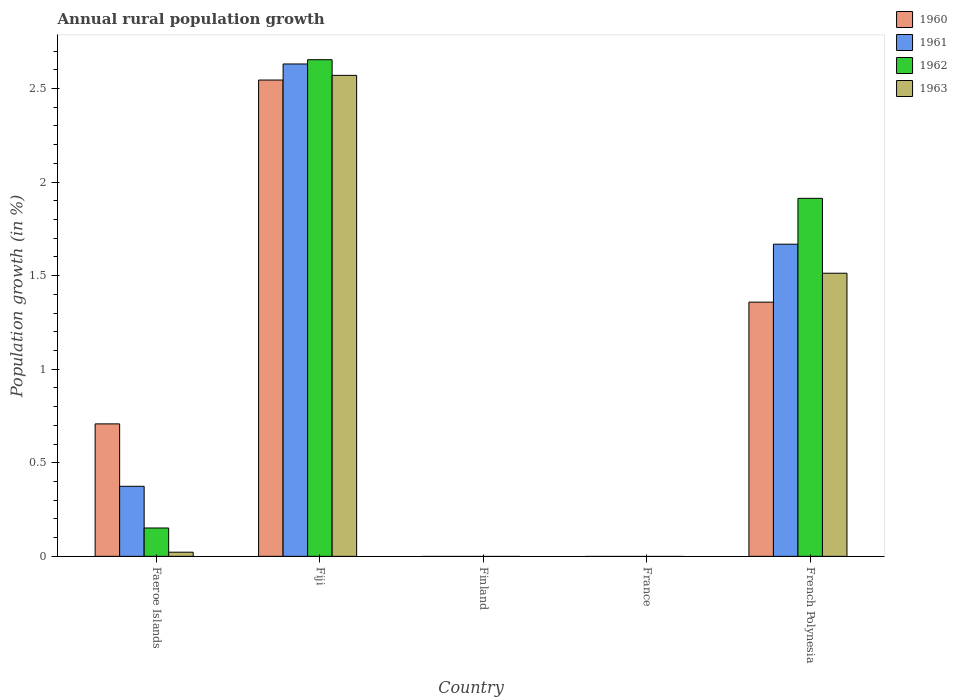Are the number of bars per tick equal to the number of legend labels?
Your response must be concise. No. How many bars are there on the 2nd tick from the left?
Offer a terse response. 4. What is the label of the 2nd group of bars from the left?
Provide a short and direct response. Fiji. In how many cases, is the number of bars for a given country not equal to the number of legend labels?
Offer a terse response. 2. Across all countries, what is the maximum percentage of rural population growth in 1963?
Offer a very short reply. 2.57. Across all countries, what is the minimum percentage of rural population growth in 1961?
Your answer should be very brief. 0. In which country was the percentage of rural population growth in 1962 maximum?
Your response must be concise. Fiji. What is the total percentage of rural population growth in 1961 in the graph?
Offer a very short reply. 4.67. What is the difference between the percentage of rural population growth in 1962 in Faeroe Islands and that in French Polynesia?
Your answer should be compact. -1.76. What is the difference between the percentage of rural population growth in 1963 in Fiji and the percentage of rural population growth in 1960 in France?
Your response must be concise. 2.57. What is the average percentage of rural population growth in 1962 per country?
Offer a very short reply. 0.94. What is the difference between the percentage of rural population growth of/in 1962 and percentage of rural population growth of/in 1961 in Fiji?
Provide a short and direct response. 0.02. In how many countries, is the percentage of rural population growth in 1963 greater than 2.4 %?
Offer a very short reply. 1. Is the difference between the percentage of rural population growth in 1962 in Fiji and French Polynesia greater than the difference between the percentage of rural population growth in 1961 in Fiji and French Polynesia?
Give a very brief answer. No. What is the difference between the highest and the second highest percentage of rural population growth in 1962?
Provide a succinct answer. -1.76. What is the difference between the highest and the lowest percentage of rural population growth in 1963?
Offer a terse response. 2.57. In how many countries, is the percentage of rural population growth in 1963 greater than the average percentage of rural population growth in 1963 taken over all countries?
Provide a short and direct response. 2. Is it the case that in every country, the sum of the percentage of rural population growth in 1963 and percentage of rural population growth in 1962 is greater than the percentage of rural population growth in 1960?
Offer a terse response. No. Are the values on the major ticks of Y-axis written in scientific E-notation?
Make the answer very short. No. Does the graph contain grids?
Your answer should be compact. No. Where does the legend appear in the graph?
Provide a short and direct response. Top right. How many legend labels are there?
Provide a succinct answer. 4. What is the title of the graph?
Offer a terse response. Annual rural population growth. Does "2000" appear as one of the legend labels in the graph?
Your answer should be very brief. No. What is the label or title of the X-axis?
Your answer should be very brief. Country. What is the label or title of the Y-axis?
Your answer should be very brief. Population growth (in %). What is the Population growth (in %) in 1960 in Faeroe Islands?
Ensure brevity in your answer.  0.71. What is the Population growth (in %) of 1961 in Faeroe Islands?
Offer a very short reply. 0.37. What is the Population growth (in %) in 1962 in Faeroe Islands?
Keep it short and to the point. 0.15. What is the Population growth (in %) in 1963 in Faeroe Islands?
Make the answer very short. 0.02. What is the Population growth (in %) in 1960 in Fiji?
Offer a very short reply. 2.54. What is the Population growth (in %) of 1961 in Fiji?
Offer a very short reply. 2.63. What is the Population growth (in %) of 1962 in Fiji?
Your response must be concise. 2.65. What is the Population growth (in %) of 1963 in Fiji?
Ensure brevity in your answer.  2.57. What is the Population growth (in %) of 1963 in Finland?
Give a very brief answer. 0. What is the Population growth (in %) of 1960 in France?
Provide a succinct answer. 0. What is the Population growth (in %) of 1960 in French Polynesia?
Provide a succinct answer. 1.36. What is the Population growth (in %) of 1961 in French Polynesia?
Provide a succinct answer. 1.67. What is the Population growth (in %) of 1962 in French Polynesia?
Offer a very short reply. 1.91. What is the Population growth (in %) of 1963 in French Polynesia?
Make the answer very short. 1.51. Across all countries, what is the maximum Population growth (in %) of 1960?
Offer a terse response. 2.54. Across all countries, what is the maximum Population growth (in %) of 1961?
Offer a terse response. 2.63. Across all countries, what is the maximum Population growth (in %) of 1962?
Your answer should be very brief. 2.65. Across all countries, what is the maximum Population growth (in %) of 1963?
Ensure brevity in your answer.  2.57. What is the total Population growth (in %) in 1960 in the graph?
Provide a succinct answer. 4.61. What is the total Population growth (in %) of 1961 in the graph?
Offer a terse response. 4.67. What is the total Population growth (in %) in 1962 in the graph?
Your response must be concise. 4.72. What is the total Population growth (in %) in 1963 in the graph?
Give a very brief answer. 4.1. What is the difference between the Population growth (in %) of 1960 in Faeroe Islands and that in Fiji?
Provide a short and direct response. -1.84. What is the difference between the Population growth (in %) in 1961 in Faeroe Islands and that in Fiji?
Provide a succinct answer. -2.26. What is the difference between the Population growth (in %) of 1962 in Faeroe Islands and that in Fiji?
Offer a very short reply. -2.5. What is the difference between the Population growth (in %) of 1963 in Faeroe Islands and that in Fiji?
Your answer should be compact. -2.55. What is the difference between the Population growth (in %) in 1960 in Faeroe Islands and that in French Polynesia?
Provide a succinct answer. -0.65. What is the difference between the Population growth (in %) of 1961 in Faeroe Islands and that in French Polynesia?
Give a very brief answer. -1.29. What is the difference between the Population growth (in %) in 1962 in Faeroe Islands and that in French Polynesia?
Provide a short and direct response. -1.76. What is the difference between the Population growth (in %) in 1963 in Faeroe Islands and that in French Polynesia?
Provide a short and direct response. -1.49. What is the difference between the Population growth (in %) of 1960 in Fiji and that in French Polynesia?
Your answer should be compact. 1.19. What is the difference between the Population growth (in %) in 1961 in Fiji and that in French Polynesia?
Your answer should be very brief. 0.96. What is the difference between the Population growth (in %) of 1962 in Fiji and that in French Polynesia?
Provide a short and direct response. 0.74. What is the difference between the Population growth (in %) of 1963 in Fiji and that in French Polynesia?
Make the answer very short. 1.06. What is the difference between the Population growth (in %) in 1960 in Faeroe Islands and the Population growth (in %) in 1961 in Fiji?
Give a very brief answer. -1.92. What is the difference between the Population growth (in %) in 1960 in Faeroe Islands and the Population growth (in %) in 1962 in Fiji?
Keep it short and to the point. -1.95. What is the difference between the Population growth (in %) in 1960 in Faeroe Islands and the Population growth (in %) in 1963 in Fiji?
Give a very brief answer. -1.86. What is the difference between the Population growth (in %) in 1961 in Faeroe Islands and the Population growth (in %) in 1962 in Fiji?
Give a very brief answer. -2.28. What is the difference between the Population growth (in %) of 1961 in Faeroe Islands and the Population growth (in %) of 1963 in Fiji?
Keep it short and to the point. -2.2. What is the difference between the Population growth (in %) of 1962 in Faeroe Islands and the Population growth (in %) of 1963 in Fiji?
Ensure brevity in your answer.  -2.42. What is the difference between the Population growth (in %) in 1960 in Faeroe Islands and the Population growth (in %) in 1961 in French Polynesia?
Make the answer very short. -0.96. What is the difference between the Population growth (in %) in 1960 in Faeroe Islands and the Population growth (in %) in 1962 in French Polynesia?
Ensure brevity in your answer.  -1.21. What is the difference between the Population growth (in %) in 1960 in Faeroe Islands and the Population growth (in %) in 1963 in French Polynesia?
Your response must be concise. -0.8. What is the difference between the Population growth (in %) of 1961 in Faeroe Islands and the Population growth (in %) of 1962 in French Polynesia?
Provide a short and direct response. -1.54. What is the difference between the Population growth (in %) in 1961 in Faeroe Islands and the Population growth (in %) in 1963 in French Polynesia?
Offer a terse response. -1.14. What is the difference between the Population growth (in %) in 1962 in Faeroe Islands and the Population growth (in %) in 1963 in French Polynesia?
Your answer should be compact. -1.36. What is the difference between the Population growth (in %) in 1960 in Fiji and the Population growth (in %) in 1961 in French Polynesia?
Offer a very short reply. 0.88. What is the difference between the Population growth (in %) of 1960 in Fiji and the Population growth (in %) of 1962 in French Polynesia?
Keep it short and to the point. 0.63. What is the difference between the Population growth (in %) in 1960 in Fiji and the Population growth (in %) in 1963 in French Polynesia?
Make the answer very short. 1.03. What is the difference between the Population growth (in %) in 1961 in Fiji and the Population growth (in %) in 1962 in French Polynesia?
Make the answer very short. 0.72. What is the difference between the Population growth (in %) of 1961 in Fiji and the Population growth (in %) of 1963 in French Polynesia?
Provide a succinct answer. 1.12. What is the difference between the Population growth (in %) of 1962 in Fiji and the Population growth (in %) of 1963 in French Polynesia?
Offer a terse response. 1.14. What is the average Population growth (in %) of 1960 per country?
Give a very brief answer. 0.92. What is the average Population growth (in %) in 1961 per country?
Keep it short and to the point. 0.93. What is the average Population growth (in %) in 1962 per country?
Give a very brief answer. 0.94. What is the average Population growth (in %) in 1963 per country?
Provide a succinct answer. 0.82. What is the difference between the Population growth (in %) of 1960 and Population growth (in %) of 1961 in Faeroe Islands?
Ensure brevity in your answer.  0.33. What is the difference between the Population growth (in %) in 1960 and Population growth (in %) in 1962 in Faeroe Islands?
Your answer should be very brief. 0.56. What is the difference between the Population growth (in %) of 1960 and Population growth (in %) of 1963 in Faeroe Islands?
Keep it short and to the point. 0.69. What is the difference between the Population growth (in %) in 1961 and Population growth (in %) in 1962 in Faeroe Islands?
Provide a short and direct response. 0.22. What is the difference between the Population growth (in %) in 1961 and Population growth (in %) in 1963 in Faeroe Islands?
Make the answer very short. 0.35. What is the difference between the Population growth (in %) in 1962 and Population growth (in %) in 1963 in Faeroe Islands?
Your answer should be very brief. 0.13. What is the difference between the Population growth (in %) of 1960 and Population growth (in %) of 1961 in Fiji?
Offer a terse response. -0.09. What is the difference between the Population growth (in %) of 1960 and Population growth (in %) of 1962 in Fiji?
Provide a short and direct response. -0.11. What is the difference between the Population growth (in %) in 1960 and Population growth (in %) in 1963 in Fiji?
Your answer should be very brief. -0.03. What is the difference between the Population growth (in %) in 1961 and Population growth (in %) in 1962 in Fiji?
Ensure brevity in your answer.  -0.02. What is the difference between the Population growth (in %) of 1961 and Population growth (in %) of 1963 in Fiji?
Give a very brief answer. 0.06. What is the difference between the Population growth (in %) of 1962 and Population growth (in %) of 1963 in Fiji?
Make the answer very short. 0.08. What is the difference between the Population growth (in %) in 1960 and Population growth (in %) in 1961 in French Polynesia?
Offer a very short reply. -0.31. What is the difference between the Population growth (in %) in 1960 and Population growth (in %) in 1962 in French Polynesia?
Provide a succinct answer. -0.55. What is the difference between the Population growth (in %) of 1960 and Population growth (in %) of 1963 in French Polynesia?
Ensure brevity in your answer.  -0.15. What is the difference between the Population growth (in %) in 1961 and Population growth (in %) in 1962 in French Polynesia?
Your response must be concise. -0.24. What is the difference between the Population growth (in %) of 1961 and Population growth (in %) of 1963 in French Polynesia?
Keep it short and to the point. 0.16. What is the ratio of the Population growth (in %) in 1960 in Faeroe Islands to that in Fiji?
Offer a terse response. 0.28. What is the ratio of the Population growth (in %) of 1961 in Faeroe Islands to that in Fiji?
Ensure brevity in your answer.  0.14. What is the ratio of the Population growth (in %) of 1962 in Faeroe Islands to that in Fiji?
Ensure brevity in your answer.  0.06. What is the ratio of the Population growth (in %) in 1963 in Faeroe Islands to that in Fiji?
Your answer should be very brief. 0.01. What is the ratio of the Population growth (in %) of 1960 in Faeroe Islands to that in French Polynesia?
Your response must be concise. 0.52. What is the ratio of the Population growth (in %) in 1961 in Faeroe Islands to that in French Polynesia?
Your answer should be very brief. 0.22. What is the ratio of the Population growth (in %) of 1962 in Faeroe Islands to that in French Polynesia?
Ensure brevity in your answer.  0.08. What is the ratio of the Population growth (in %) of 1963 in Faeroe Islands to that in French Polynesia?
Keep it short and to the point. 0.01. What is the ratio of the Population growth (in %) of 1960 in Fiji to that in French Polynesia?
Give a very brief answer. 1.87. What is the ratio of the Population growth (in %) of 1961 in Fiji to that in French Polynesia?
Provide a short and direct response. 1.58. What is the ratio of the Population growth (in %) in 1962 in Fiji to that in French Polynesia?
Your response must be concise. 1.39. What is the ratio of the Population growth (in %) of 1963 in Fiji to that in French Polynesia?
Offer a very short reply. 1.7. What is the difference between the highest and the second highest Population growth (in %) in 1960?
Offer a very short reply. 1.19. What is the difference between the highest and the second highest Population growth (in %) in 1961?
Ensure brevity in your answer.  0.96. What is the difference between the highest and the second highest Population growth (in %) in 1962?
Your answer should be very brief. 0.74. What is the difference between the highest and the second highest Population growth (in %) of 1963?
Ensure brevity in your answer.  1.06. What is the difference between the highest and the lowest Population growth (in %) in 1960?
Offer a very short reply. 2.54. What is the difference between the highest and the lowest Population growth (in %) of 1961?
Make the answer very short. 2.63. What is the difference between the highest and the lowest Population growth (in %) of 1962?
Give a very brief answer. 2.65. What is the difference between the highest and the lowest Population growth (in %) in 1963?
Your response must be concise. 2.57. 